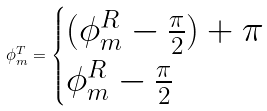<formula> <loc_0><loc_0><loc_500><loc_500>\phi ^ { T } _ { m } = \begin{cases} ( \phi ^ { R } _ { m } - \frac { \pi } { 2 } ) + \pi & \\ \phi ^ { R } _ { m } - \frac { \pi } { 2 } & \end{cases}</formula> 